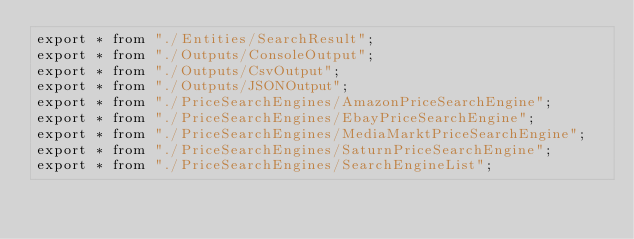Convert code to text. <code><loc_0><loc_0><loc_500><loc_500><_TypeScript_>export * from "./Entities/SearchResult";
export * from "./Outputs/ConsoleOutput";
export * from "./Outputs/CsvOutput";
export * from "./Outputs/JSONOutput";
export * from "./PriceSearchEngines/AmazonPriceSearchEngine";
export * from "./PriceSearchEngines/EbayPriceSearchEngine";
export * from "./PriceSearchEngines/MediaMarktPriceSearchEngine";
export * from "./PriceSearchEngines/SaturnPriceSearchEngine";
export * from "./PriceSearchEngines/SearchEngineList";</code> 